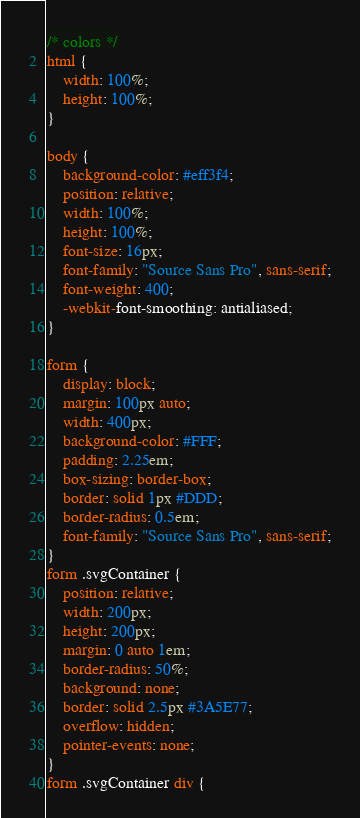Convert code to text. <code><loc_0><loc_0><loc_500><loc_500><_CSS_>/* colors */
html {
    width: 100%;
    height: 100%;
}

body {
    background-color: #eff3f4;
    position: relative;
    width: 100%;
    height: 100%;
    font-size: 16px;
    font-family: "Source Sans Pro", sans-serif;
    font-weight: 400;
    -webkit-font-smoothing: antialiased;
}

form {
    display: block;
    margin: 100px auto;
    width: 400px;
    background-color: #FFF;
    padding: 2.25em;
    box-sizing: border-box;
    border: solid 1px #DDD;
    border-radius: 0.5em;
    font-family: "Source Sans Pro", sans-serif;
}
form .svgContainer {
    position: relative;
    width: 200px;
    height: 200px;
    margin: 0 auto 1em;
    border-radius: 50%;
    background: none;
    border: solid 2.5px #3A5E77;
    overflow: hidden;
    pointer-events: none;
}
form .svgContainer div {</code> 